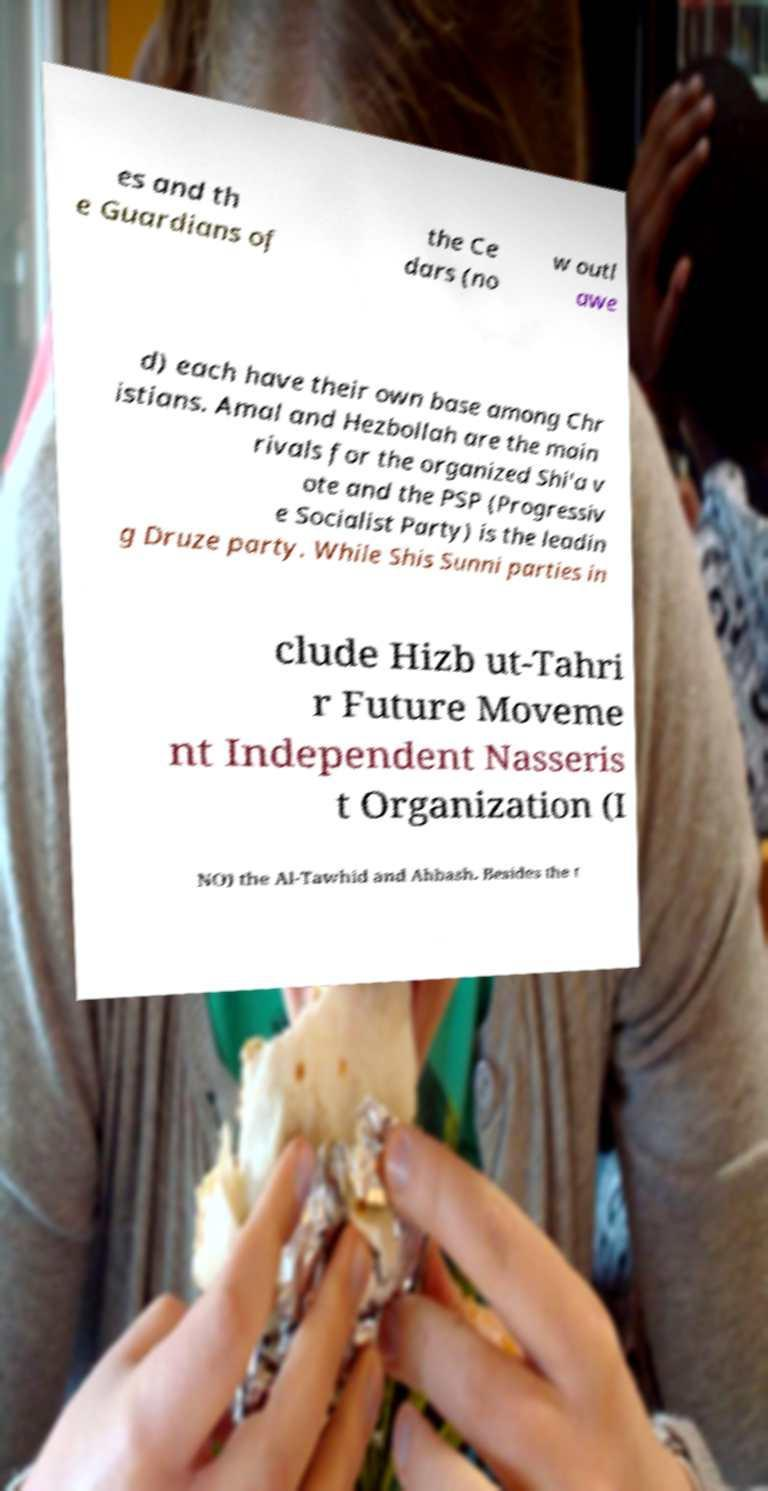There's text embedded in this image that I need extracted. Can you transcribe it verbatim? es and th e Guardians of the Ce dars (no w outl awe d) each have their own base among Chr istians. Amal and Hezbollah are the main rivals for the organized Shi'a v ote and the PSP (Progressiv e Socialist Party) is the leadin g Druze party. While Shis Sunni parties in clude Hizb ut-Tahri r Future Moveme nt Independent Nasseris t Organization (I NO) the Al-Tawhid and Ahbash. Besides the t 